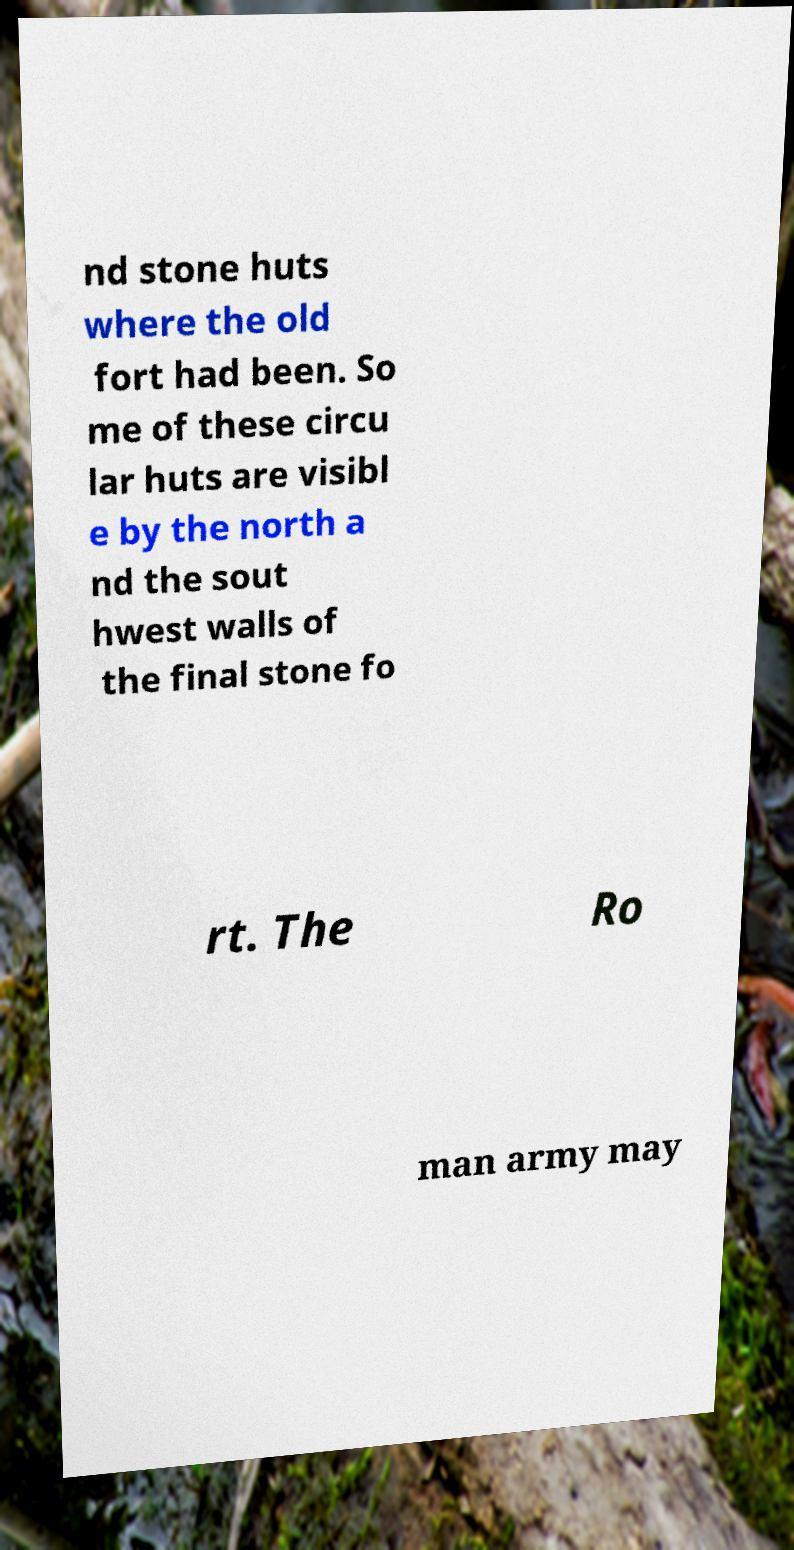Can you accurately transcribe the text from the provided image for me? nd stone huts where the old fort had been. So me of these circu lar huts are visibl e by the north a nd the sout hwest walls of the final stone fo rt. The Ro man army may 